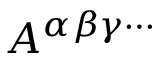Convert formula to latex. <formula><loc_0><loc_0><loc_500><loc_500>A ^ { \alpha \beta \gamma \cdots }</formula> 